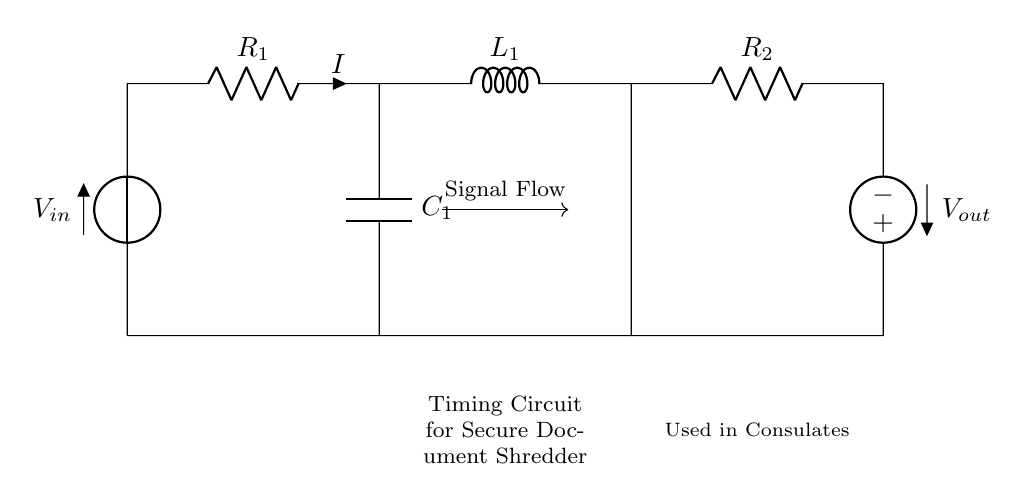What type of components are used in this circuit? The circuit includes a resistor, an inductor, and a capacitor, which are the essential components found in an RLC circuit.
Answer: Resistor, inductor, capacitor What is the purpose of the timing circuit in this design? The timing circuit in a secure document shredder determines the delay before the shredding process starts, ensuring documents are not shredded immediately upon activation.
Answer: Timing delay What is the role of the inductor in this circuit? The inductor serves to store energy in a magnetic field when current passes through it, influencing the timing behavior of the circuit.
Answer: Energy storage How many resistors are present in this circuit? There are two resistors in the circuit labeled as R1 and R2, which are responsible for controlling current flow.
Answer: Two What does the output voltage represent in this timing circuit? The output voltage indicates the voltage at the output terminal after going through the circuit, which can affect whether the shredding mechanism is engaged.
Answer: Output voltage How does the capacitor affect the timing of the circuit? The capacitor charges over time and its charge/discharge rate, determined by the resistors and inductor, influences the timing characteristics of the circuit, controlling when the shredder activates.
Answer: Timing influence What is the overall function of the components in this timing circuit? The combination of the resistor, inductor, and capacitor creates a timing delay before the shredding mechanism of the document shredder activates, enhancing security by preventing immediate shredding.
Answer: Delay mechanism 